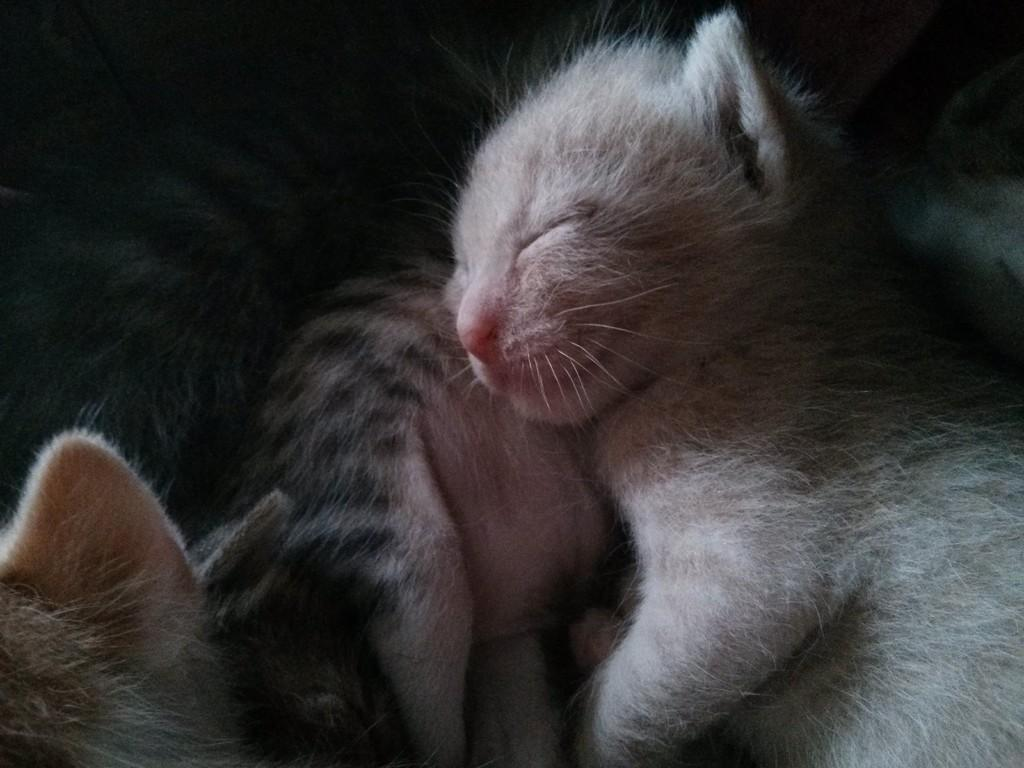What type of animals are present in the image? There are cats in the image. What are the cats doing in the image? The cats are sleeping. Can you hear the cats laughing in the image? There is no sound in the image, so it is not possible to hear the cats laughing. 